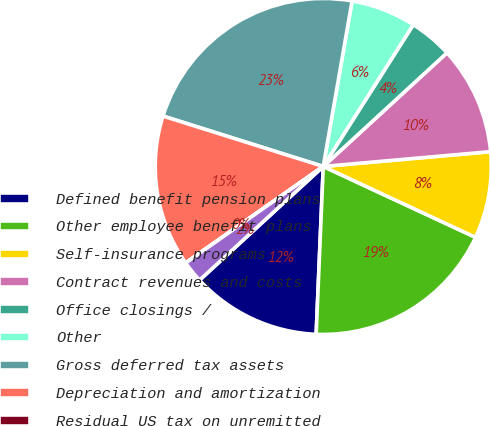Convert chart. <chart><loc_0><loc_0><loc_500><loc_500><pie_chart><fcel>Defined benefit pension plans<fcel>Other employee benefit plans<fcel>Self-insurance programs<fcel>Contract revenues and costs<fcel>Office closings /<fcel>Other<fcel>Gross deferred tax assets<fcel>Depreciation and amortization<fcel>Residual US tax on unremitted<fcel>Other net<nl><fcel>12.5%<fcel>18.74%<fcel>8.34%<fcel>10.42%<fcel>4.17%<fcel>6.26%<fcel>22.9%<fcel>14.58%<fcel>0.01%<fcel>2.09%<nl></chart> 